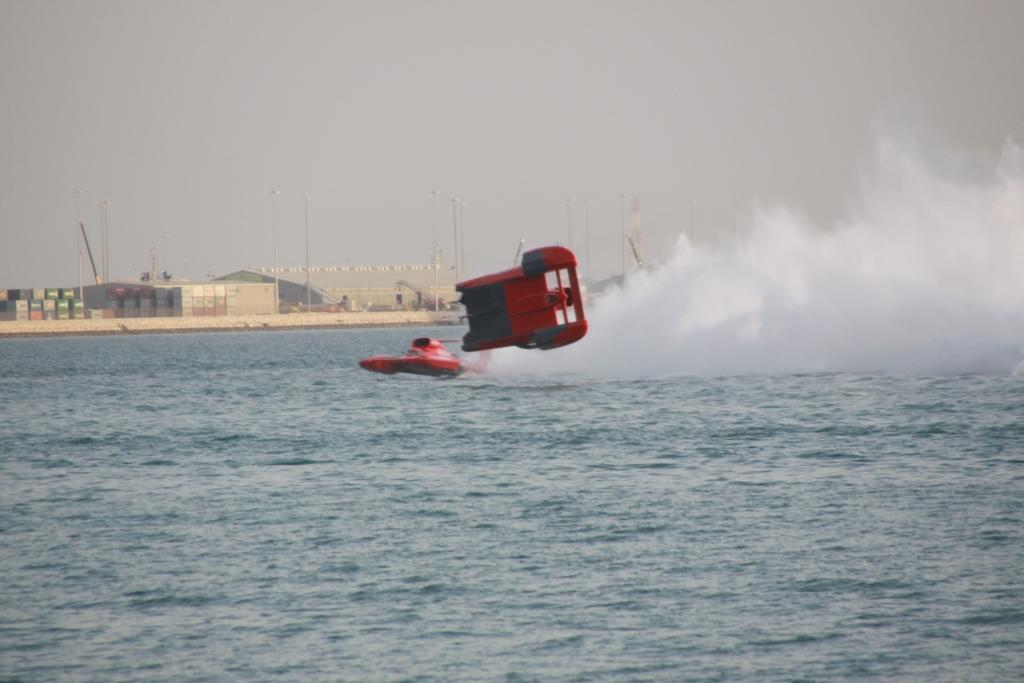What is the main subject of the image? The main subject of the image is a boat. Where is the boat located? The boat is on the water. What color is the object in the image? There is a red color object in the image. What structures can be seen in the image? There are poles, lights, and buildings in the image. What other items are present in the image? There are boxes in the image. What can be seen in the background of the image? The sky is visible in the background of the image. How many cherries are on the stove in the image? There are no cherries or stove present in the image. What type of parent can be seen interacting with the boxes in the image? There are no parents or interactions with boxes in the image. 